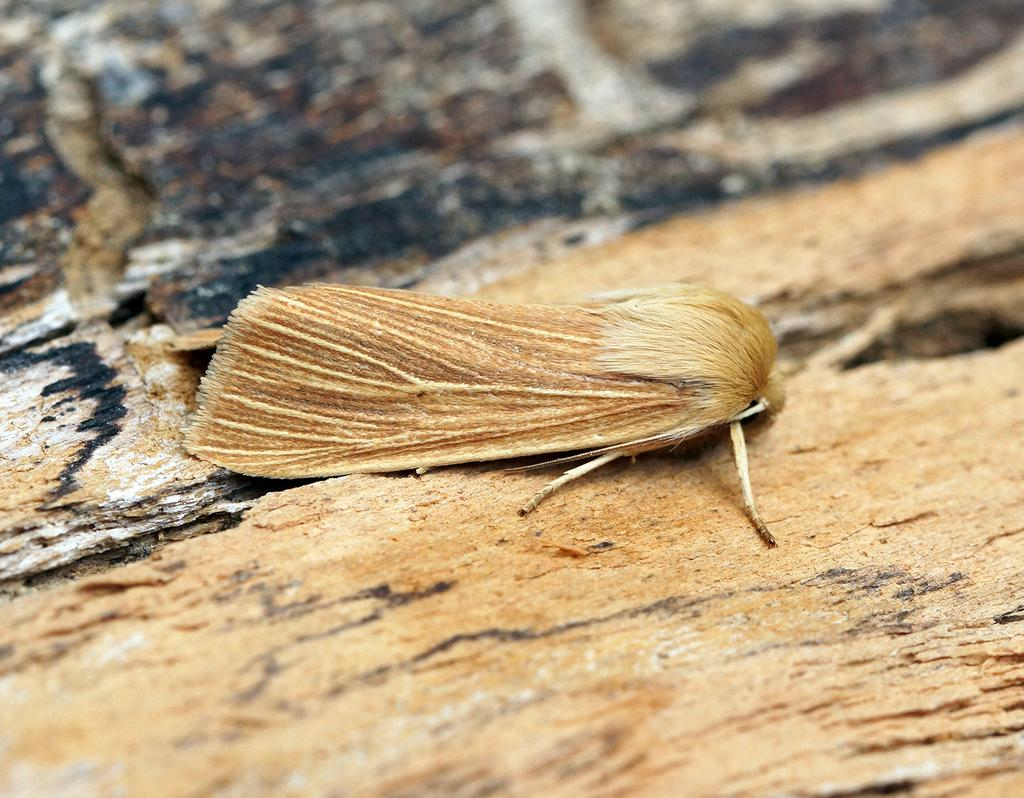What is present on the ground in the image? There is a fly on the ground in the image. What type of quiver can be seen in the image? There is no quiver present in the image; it only features a fly on the ground. 